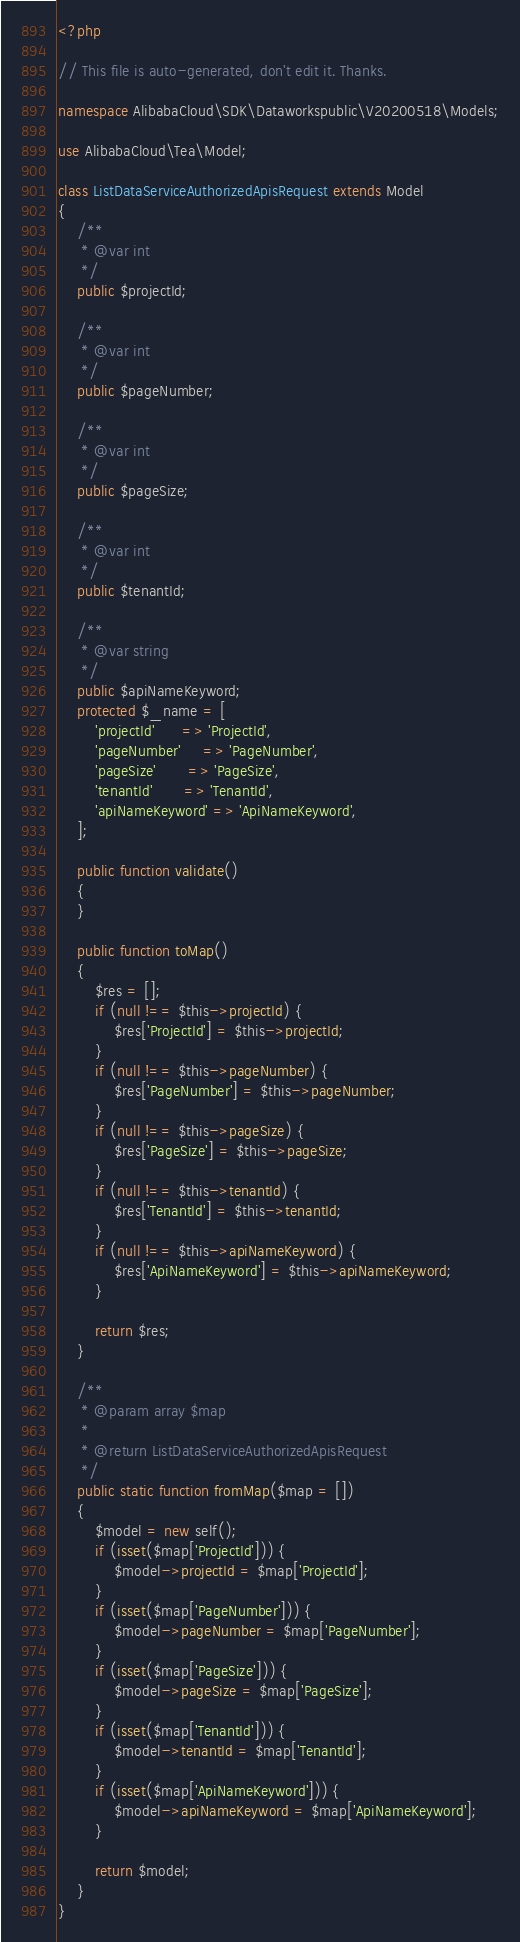<code> <loc_0><loc_0><loc_500><loc_500><_PHP_><?php

// This file is auto-generated, don't edit it. Thanks.

namespace AlibabaCloud\SDK\Dataworkspublic\V20200518\Models;

use AlibabaCloud\Tea\Model;

class ListDataServiceAuthorizedApisRequest extends Model
{
    /**
     * @var int
     */
    public $projectId;

    /**
     * @var int
     */
    public $pageNumber;

    /**
     * @var int
     */
    public $pageSize;

    /**
     * @var int
     */
    public $tenantId;

    /**
     * @var string
     */
    public $apiNameKeyword;
    protected $_name = [
        'projectId'      => 'ProjectId',
        'pageNumber'     => 'PageNumber',
        'pageSize'       => 'PageSize',
        'tenantId'       => 'TenantId',
        'apiNameKeyword' => 'ApiNameKeyword',
    ];

    public function validate()
    {
    }

    public function toMap()
    {
        $res = [];
        if (null !== $this->projectId) {
            $res['ProjectId'] = $this->projectId;
        }
        if (null !== $this->pageNumber) {
            $res['PageNumber'] = $this->pageNumber;
        }
        if (null !== $this->pageSize) {
            $res['PageSize'] = $this->pageSize;
        }
        if (null !== $this->tenantId) {
            $res['TenantId'] = $this->tenantId;
        }
        if (null !== $this->apiNameKeyword) {
            $res['ApiNameKeyword'] = $this->apiNameKeyword;
        }

        return $res;
    }

    /**
     * @param array $map
     *
     * @return ListDataServiceAuthorizedApisRequest
     */
    public static function fromMap($map = [])
    {
        $model = new self();
        if (isset($map['ProjectId'])) {
            $model->projectId = $map['ProjectId'];
        }
        if (isset($map['PageNumber'])) {
            $model->pageNumber = $map['PageNumber'];
        }
        if (isset($map['PageSize'])) {
            $model->pageSize = $map['PageSize'];
        }
        if (isset($map['TenantId'])) {
            $model->tenantId = $map['TenantId'];
        }
        if (isset($map['ApiNameKeyword'])) {
            $model->apiNameKeyword = $map['ApiNameKeyword'];
        }

        return $model;
    }
}
</code> 